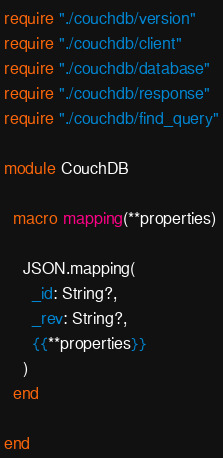Convert code to text. <code><loc_0><loc_0><loc_500><loc_500><_Crystal_>require "./couchdb/version"
require "./couchdb/client"
require "./couchdb/database"
require "./couchdb/response"
require "./couchdb/find_query"

module CouchDB

  macro mapping(**properties)

    JSON.mapping(
      _id: String?,
      _rev: String?,
      {{**properties}}
    )
  end

end
</code> 